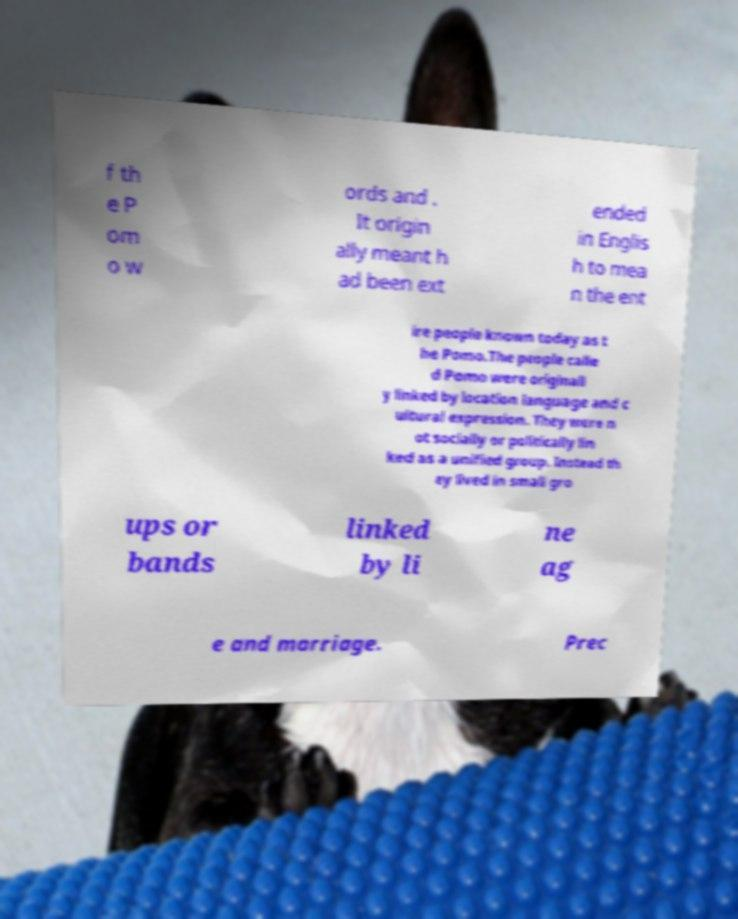Could you extract and type out the text from this image? f th e P om o w ords and . It origin ally meant h ad been ext ended in Englis h to mea n the ent ire people known today as t he Pomo.The people calle d Pomo were originall y linked by location language and c ultural expression. They were n ot socially or politically lin ked as a unified group. Instead th ey lived in small gro ups or bands linked by li ne ag e and marriage. Prec 